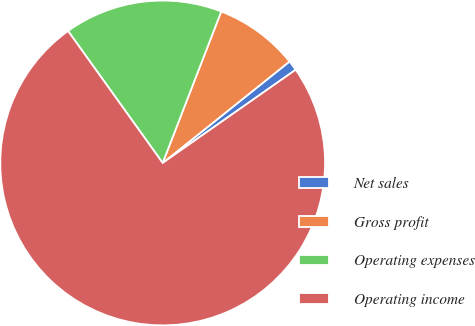Convert chart. <chart><loc_0><loc_0><loc_500><loc_500><pie_chart><fcel>Net sales<fcel>Gross profit<fcel>Operating expenses<fcel>Operating income<nl><fcel>1.01%<fcel>8.39%<fcel>15.77%<fcel>74.82%<nl></chart> 